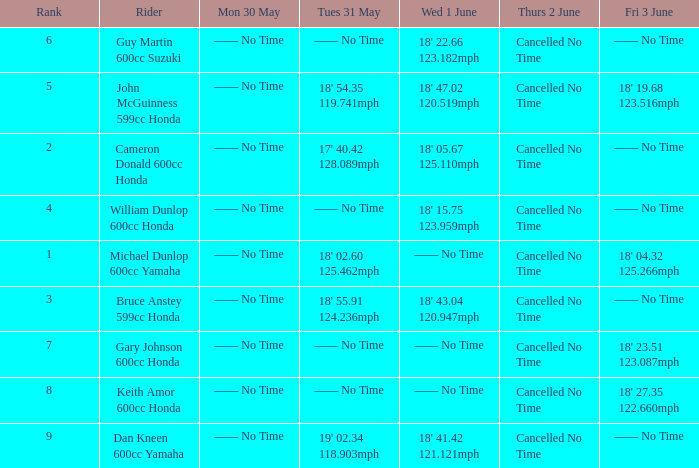What is the Fri 3 June time for the rider with a Weds 1 June time of 18' 22.66 123.182mph? —— No Time. 